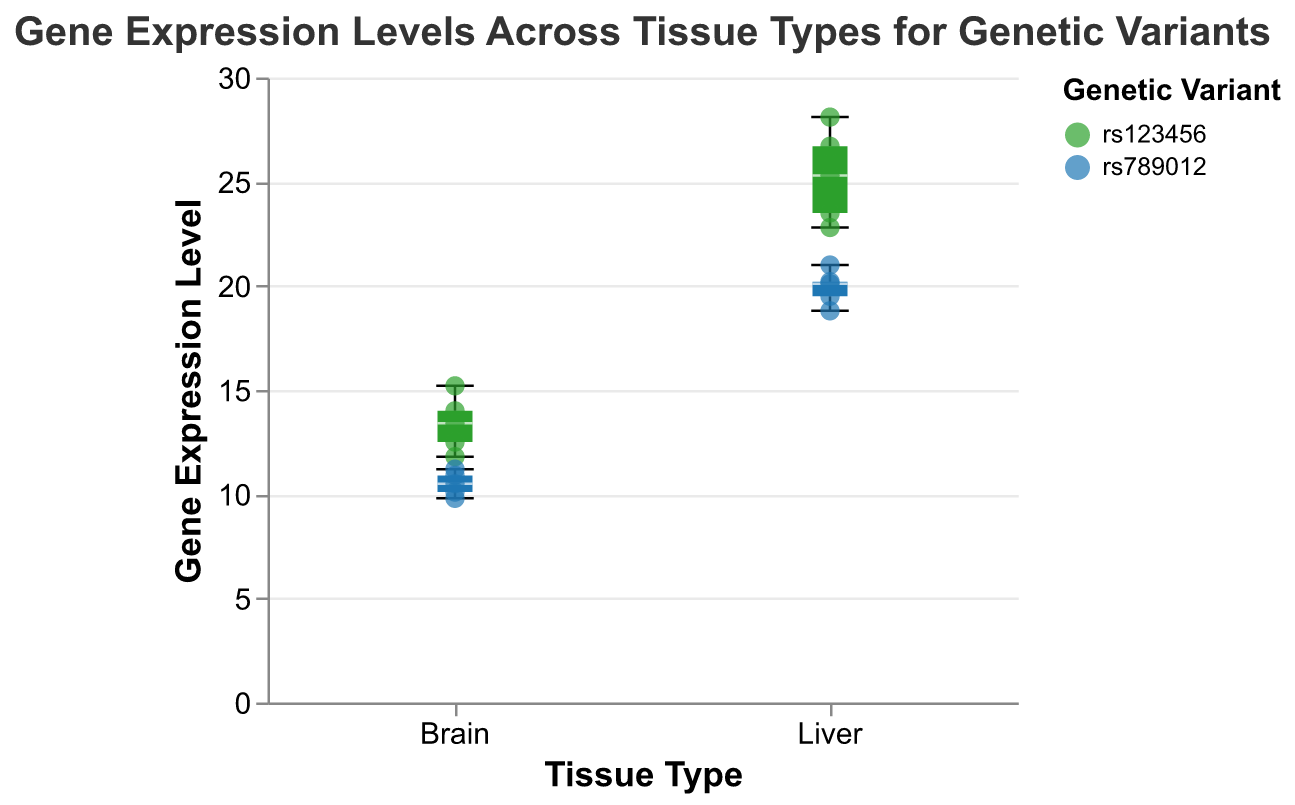What is the title of the plot? The title is displayed at the top of the plot, it reads "Gene Expression Levels Across Tissue Types for Genetic Variants".
Answer: Gene Expression Levels Across Tissue Types for Genetic Variants Which genetic variant shows higher median gene expression levels in the brain? The box plot's median line for each tissue type indicates the median expression level. For the brain, the variant rs123456 has a higher median compared to rs789012.
Answer: rs123456 How many data points are there for the brain tissue type? Both genetic variants have 5 data points each for brain tissue. Summing them up gives 5+5=10.
Answer: 10 What is the range of gene expression levels for the liver tissue type of rs789012? The range can be determined by looking at the ends of the whiskers for the liver tissue type box plot of rs789012, which extend from 18.8 to 21.0.
Answer: 18.8 to 21.0 Compare the median gene expression levels of both genetic variants in the liver tissue type. The box plots show that the median line for rs123456 in liver tissue is higher than that for rs789012.
Answer: rs123456 is higher What is the highest gene expression level recorded for any tissue type and genetic variant? The highest point on the plot marks this value, which is around 28.1, seen in the liver tissue for rs123456.
Answer: 28.1 Is there more variability in gene expression levels in brain or liver for rs123456? The length of the box and whiskers represents the variability. The liver tissue for rs123456 has longer whiskers compared to the brain, indicating more variability.
Answer: Liver What is the lowest gene expression level recorded in the plot? The lowest point falls around 9.8, observed in the brain tissue for rs789012.
Answer: 9.8 What is the median gene expression level for rs789012 in brain tissue? The median is represented by the horizontal line inside the box. For rs789012 in brain, it appears around 10.5.
Answer: 10.5 What does the white line inside the box plots represent? The white line inside each box plot represents the median gene expression level for the group.
Answer: Median gene expression level 